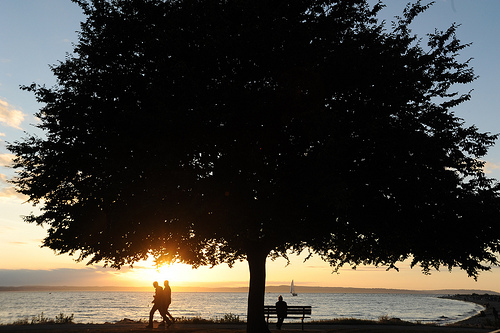<image>
Is there a people walking in front of the park bench? No. The people walking is not in front of the park bench. The spatial positioning shows a different relationship between these objects. Where is the tree in relation to the couple? Is it above the couple? Yes. The tree is positioned above the couple in the vertical space, higher up in the scene. 